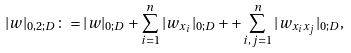Convert formula to latex. <formula><loc_0><loc_0><loc_500><loc_500>| w | _ { 0 , 2 ; D } \colon = | w | _ { 0 ; D } + \sum _ { i = 1 } ^ { n } | w _ { x _ { i } } | _ { 0 ; D } + + \sum _ { i , j = 1 } ^ { n } | w _ { x _ { i } x _ { j } } | _ { 0 ; D } ,</formula> 